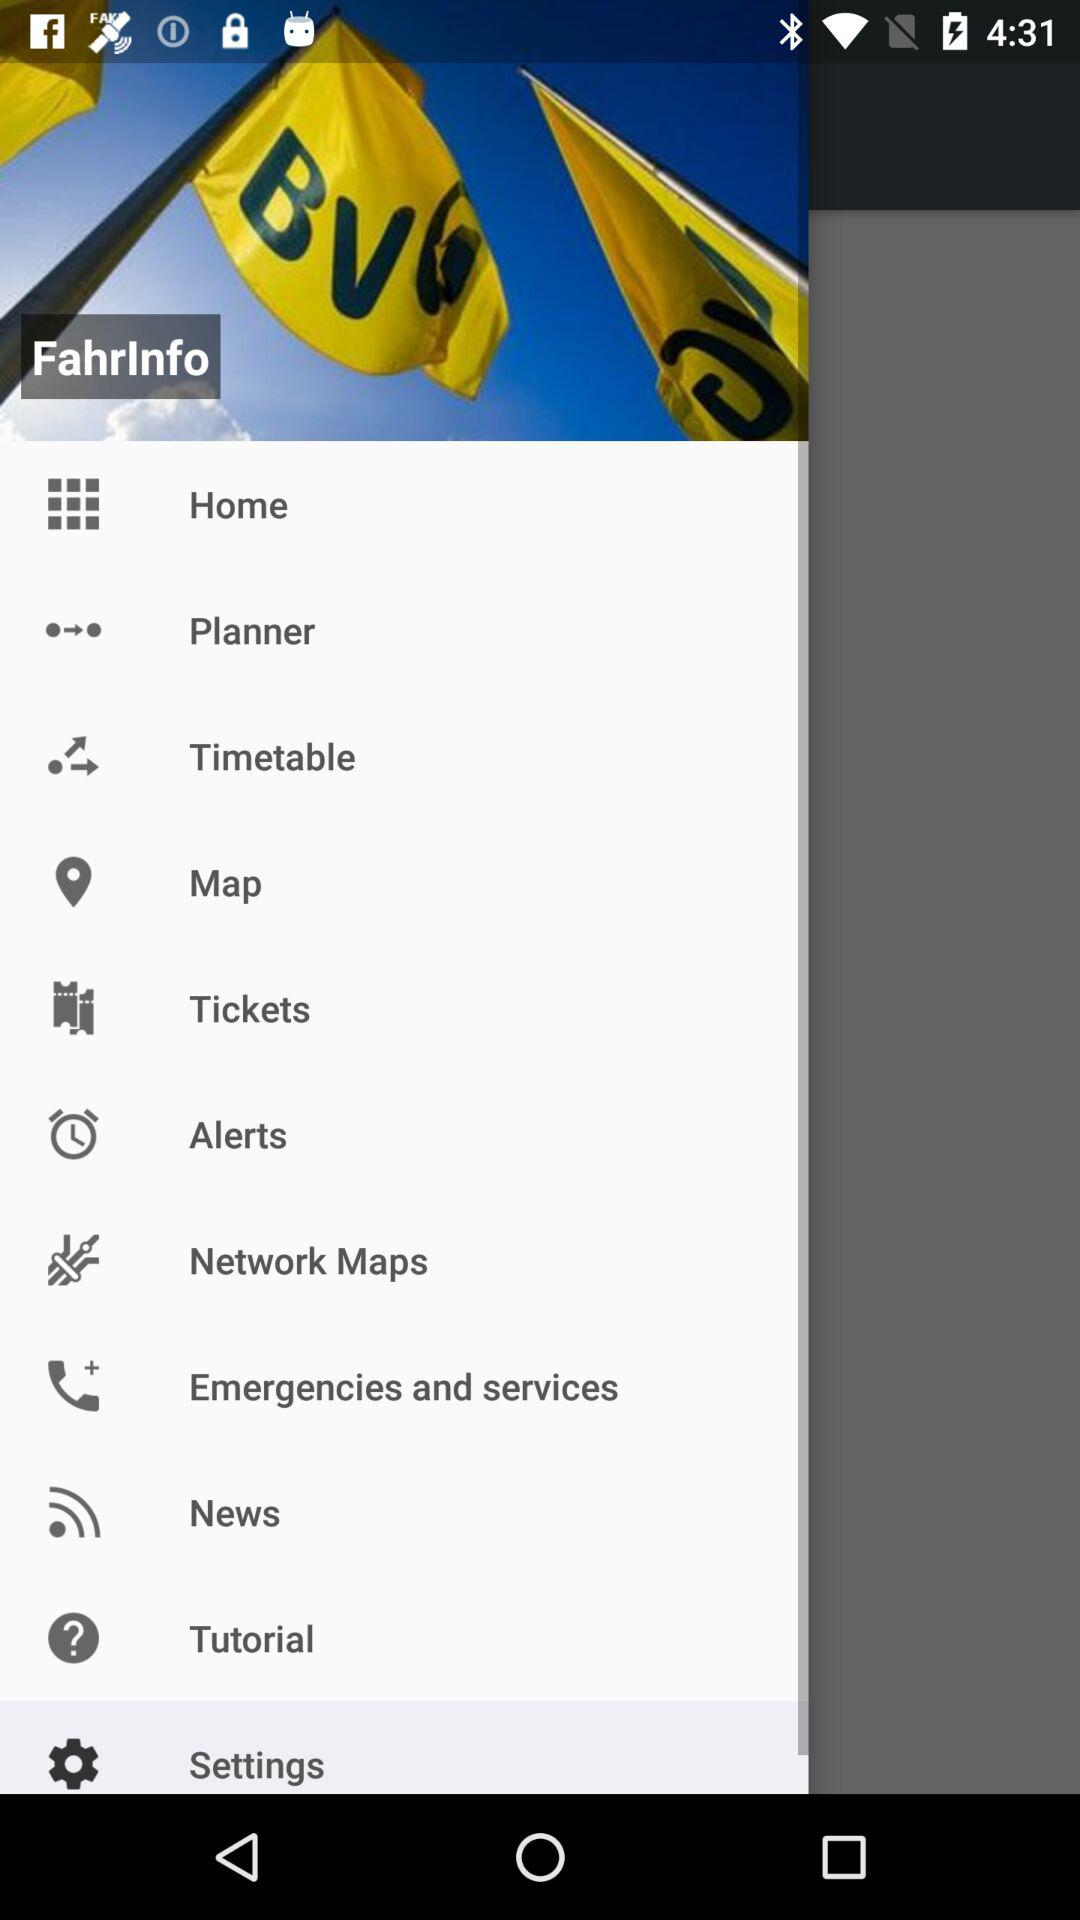What is the application name? The application name is "Fahrinfo". 